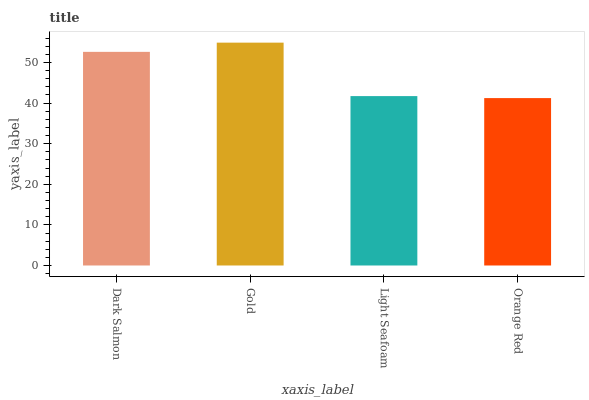Is Orange Red the minimum?
Answer yes or no. Yes. Is Gold the maximum?
Answer yes or no. Yes. Is Light Seafoam the minimum?
Answer yes or no. No. Is Light Seafoam the maximum?
Answer yes or no. No. Is Gold greater than Light Seafoam?
Answer yes or no. Yes. Is Light Seafoam less than Gold?
Answer yes or no. Yes. Is Light Seafoam greater than Gold?
Answer yes or no. No. Is Gold less than Light Seafoam?
Answer yes or no. No. Is Dark Salmon the high median?
Answer yes or no. Yes. Is Light Seafoam the low median?
Answer yes or no. Yes. Is Orange Red the high median?
Answer yes or no. No. Is Gold the low median?
Answer yes or no. No. 